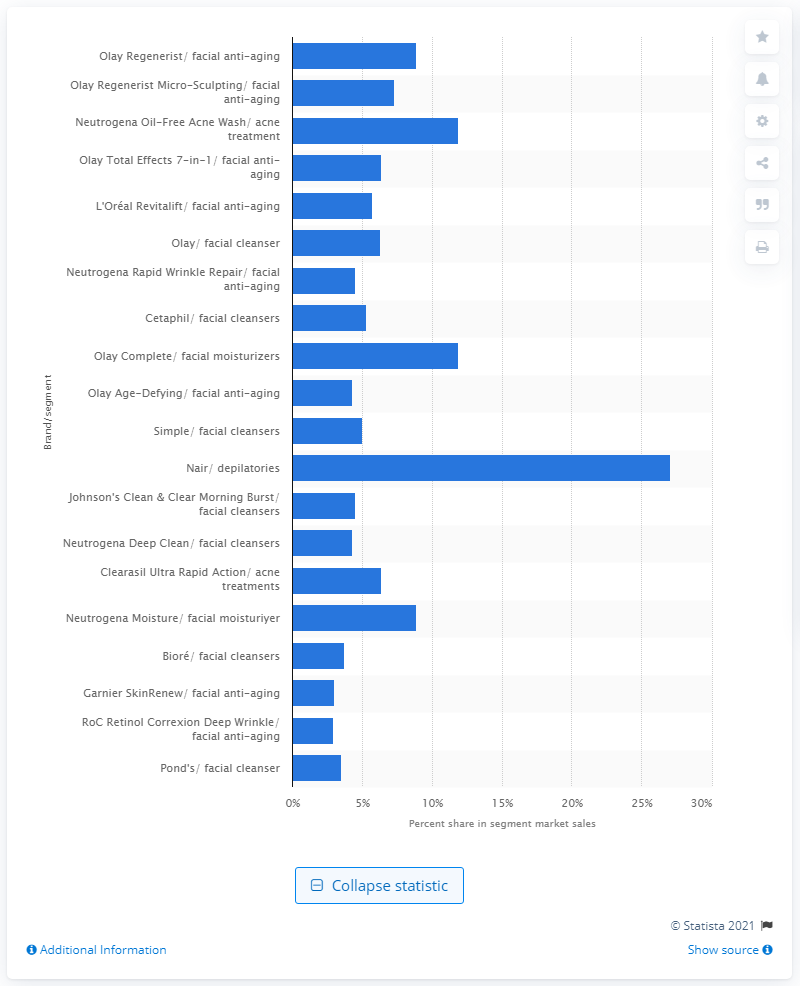Point out several critical features in this image. According to the provided data, Nair depilatories accounted for 27.1% of total sales. According to data, Olay Regenerist and Olay Regenerist Micro-Sculpting collectively accounted for 8.9% of the facial anti-aging product market. 